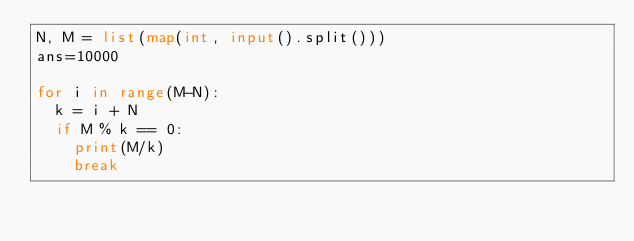Convert code to text. <code><loc_0><loc_0><loc_500><loc_500><_Python_>N, M = list(map(int, input().split()))
ans=10000

for i in range(M-N):
  k = i + N
  if M % k == 0:
    print(M/k)
    break</code> 